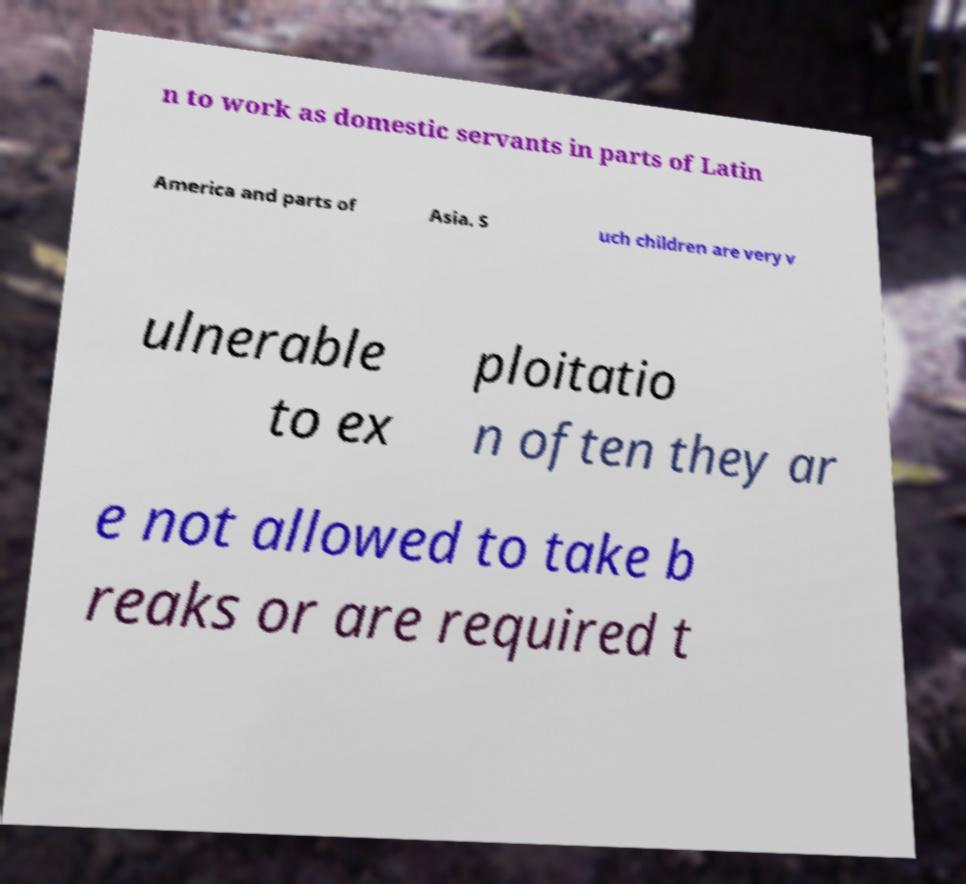Please identify and transcribe the text found in this image. n to work as domestic servants in parts of Latin America and parts of Asia. S uch children are very v ulnerable to ex ploitatio n often they ar e not allowed to take b reaks or are required t 